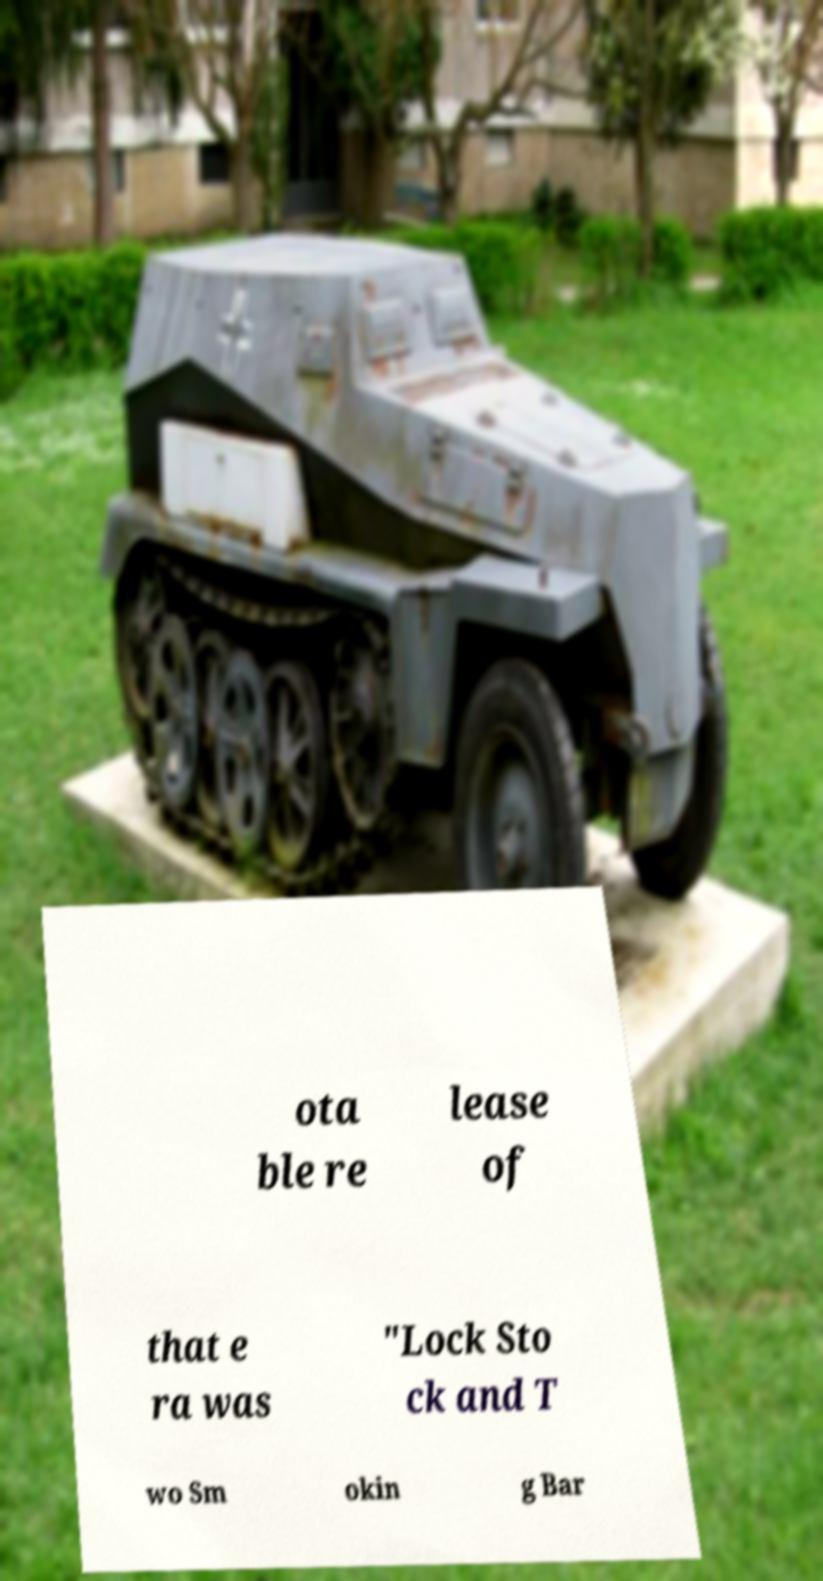Could you extract and type out the text from this image? ota ble re lease of that e ra was "Lock Sto ck and T wo Sm okin g Bar 